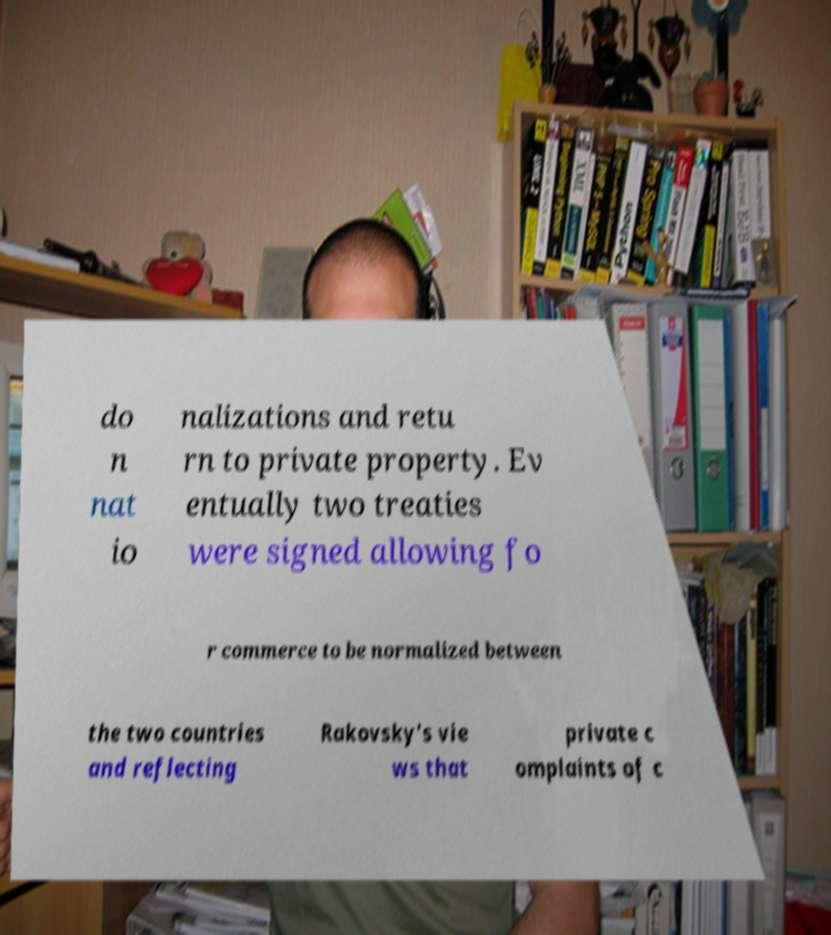What messages or text are displayed in this image? I need them in a readable, typed format. do n nat io nalizations and retu rn to private property. Ev entually two treaties were signed allowing fo r commerce to be normalized between the two countries and reflecting Rakovsky's vie ws that private c omplaints of c 